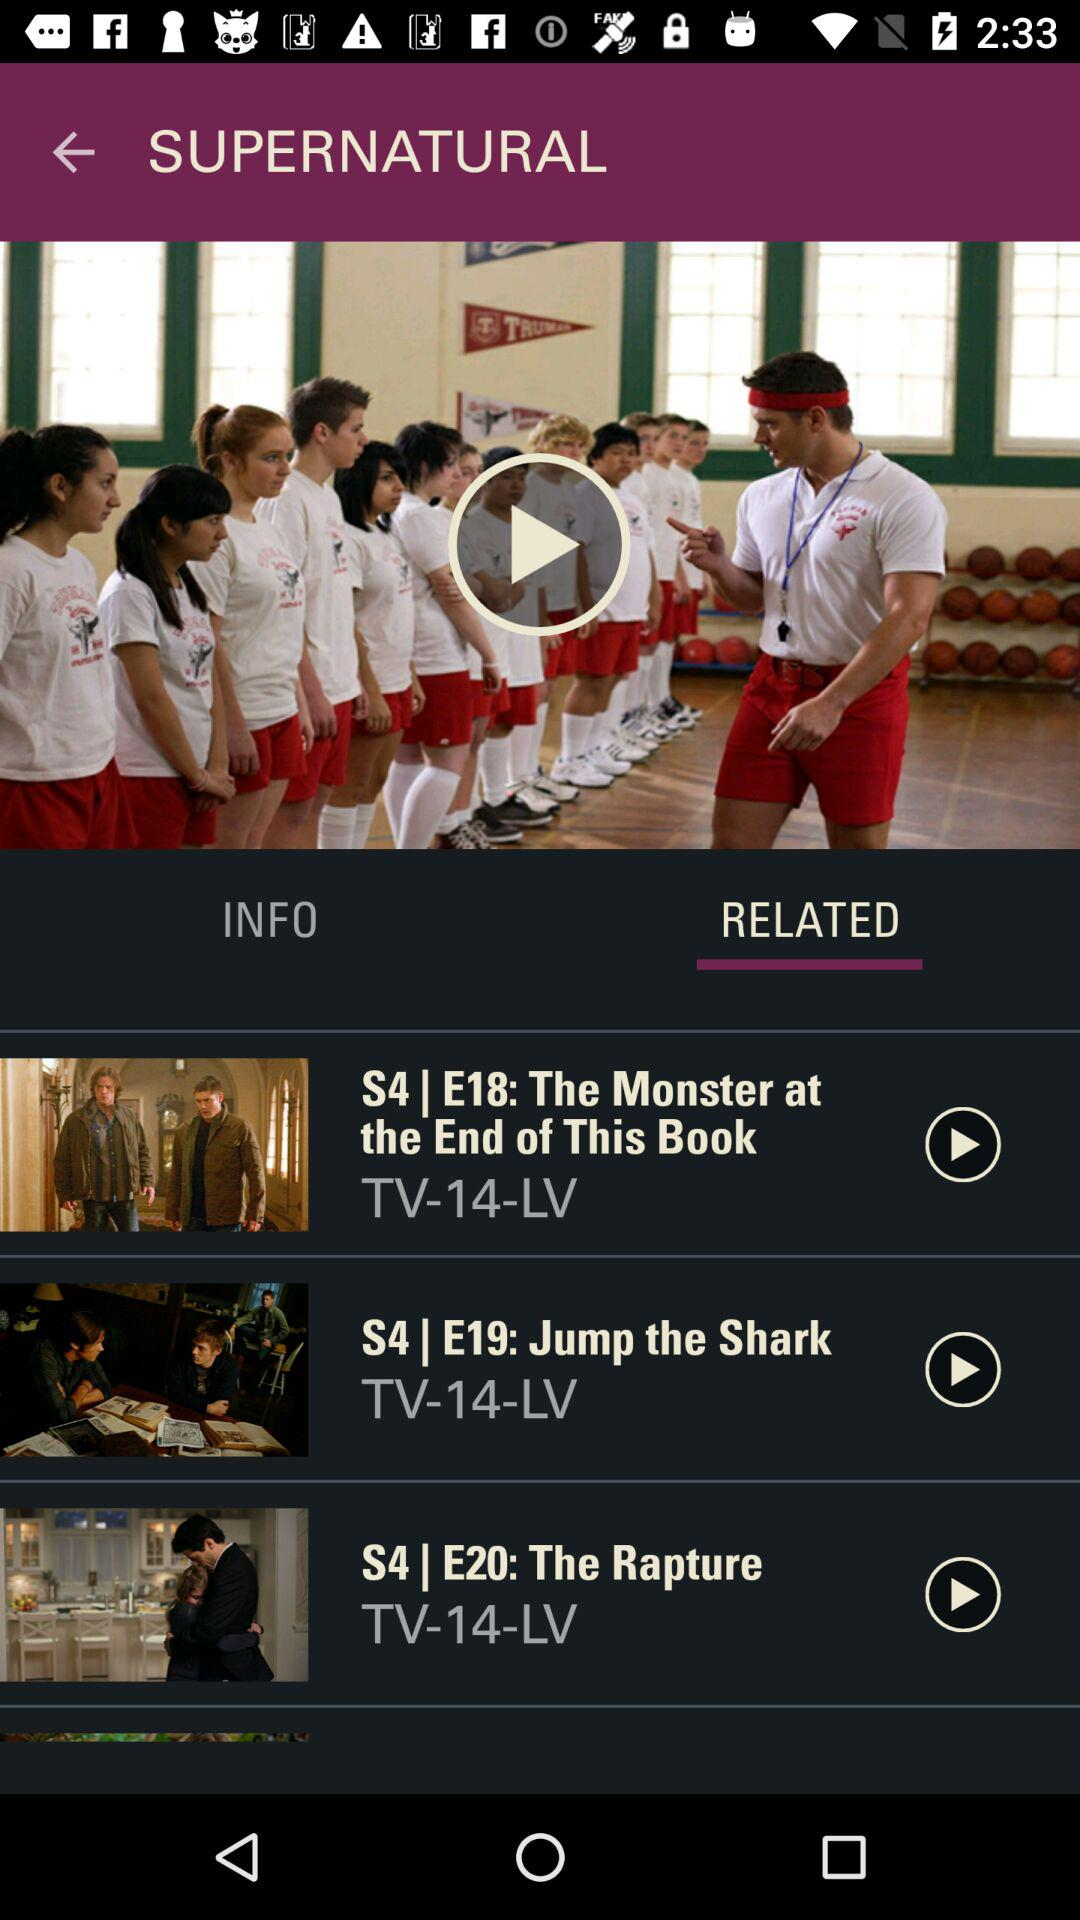Which season of The Rapture is in the playlist?
When the provided information is insufficient, respond with <no answer>. <no answer> 